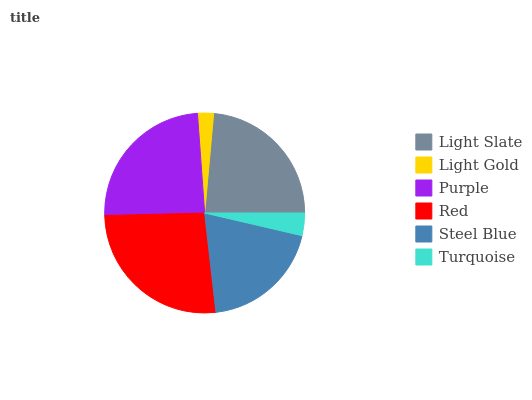Is Light Gold the minimum?
Answer yes or no. Yes. Is Red the maximum?
Answer yes or no. Yes. Is Purple the minimum?
Answer yes or no. No. Is Purple the maximum?
Answer yes or no. No. Is Purple greater than Light Gold?
Answer yes or no. Yes. Is Light Gold less than Purple?
Answer yes or no. Yes. Is Light Gold greater than Purple?
Answer yes or no. No. Is Purple less than Light Gold?
Answer yes or no. No. Is Light Slate the high median?
Answer yes or no. Yes. Is Steel Blue the low median?
Answer yes or no. Yes. Is Light Gold the high median?
Answer yes or no. No. Is Purple the low median?
Answer yes or no. No. 